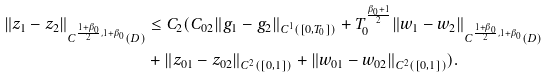<formula> <loc_0><loc_0><loc_500><loc_500>\| z _ { 1 } - z _ { 2 } \| _ { C ^ { \frac { 1 + \beta _ { 0 } } { 2 } , 1 + \beta _ { 0 } } ( D ) } & \leq C _ { 2 } ( C _ { 0 2 } \| g _ { 1 } - g _ { 2 } \| _ { C ^ { 1 } ( [ 0 , T _ { 0 } ] ) } + T _ { 0 } ^ { \frac { \beta _ { 0 } + 1 } { 2 } } \| w _ { 1 } - w _ { 2 } \| _ { C ^ { \frac { 1 + \beta _ { 0 } } { 2 } , 1 + \beta _ { 0 } } ( D ) } \\ & + \| z _ { 0 1 } - z _ { 0 2 } \| _ { C ^ { 2 } ( [ 0 , 1 ] ) } + \| w _ { 0 1 } - w _ { 0 2 } \| _ { C ^ { 2 } ( [ 0 , 1 ] ) } ) . \\</formula> 